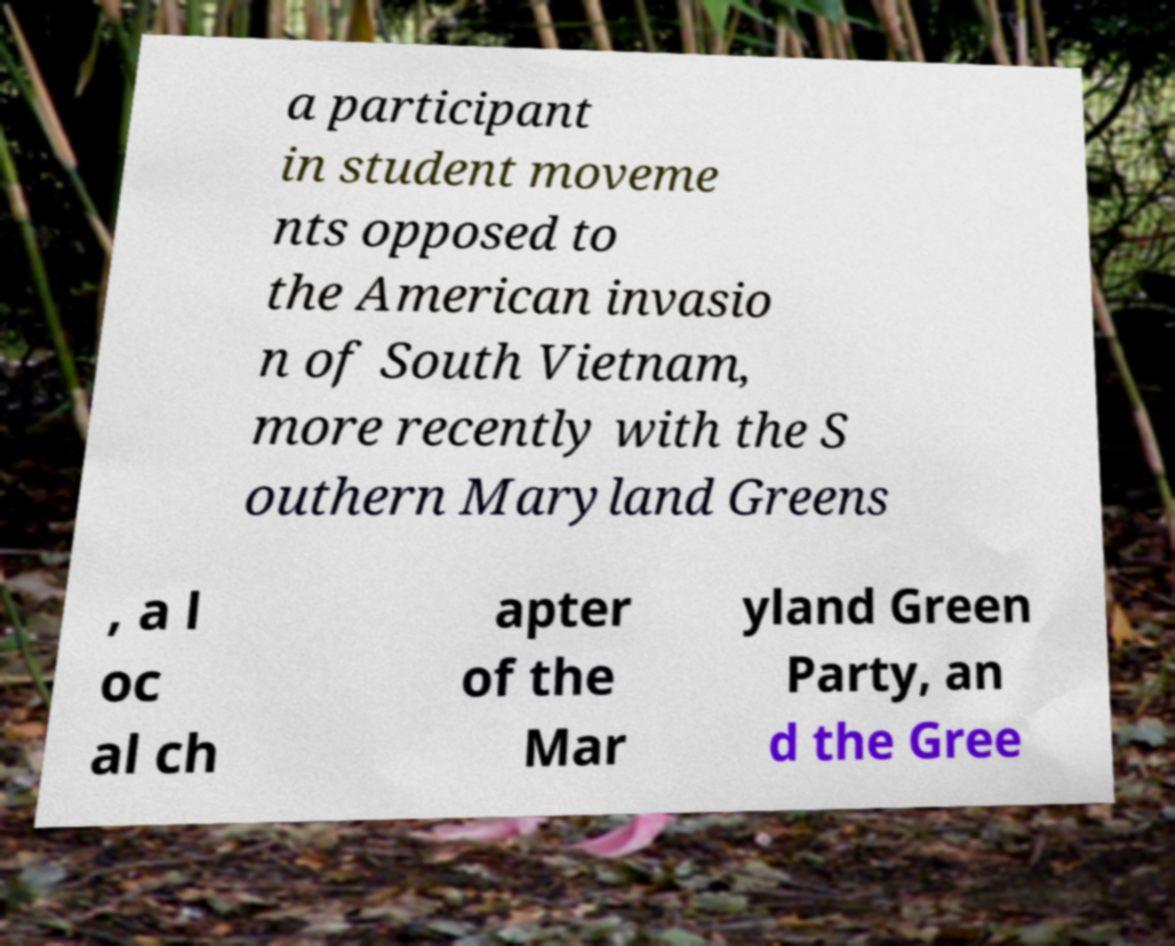Could you assist in decoding the text presented in this image and type it out clearly? a participant in student moveme nts opposed to the American invasio n of South Vietnam, more recently with the S outhern Maryland Greens , a l oc al ch apter of the Mar yland Green Party, an d the Gree 